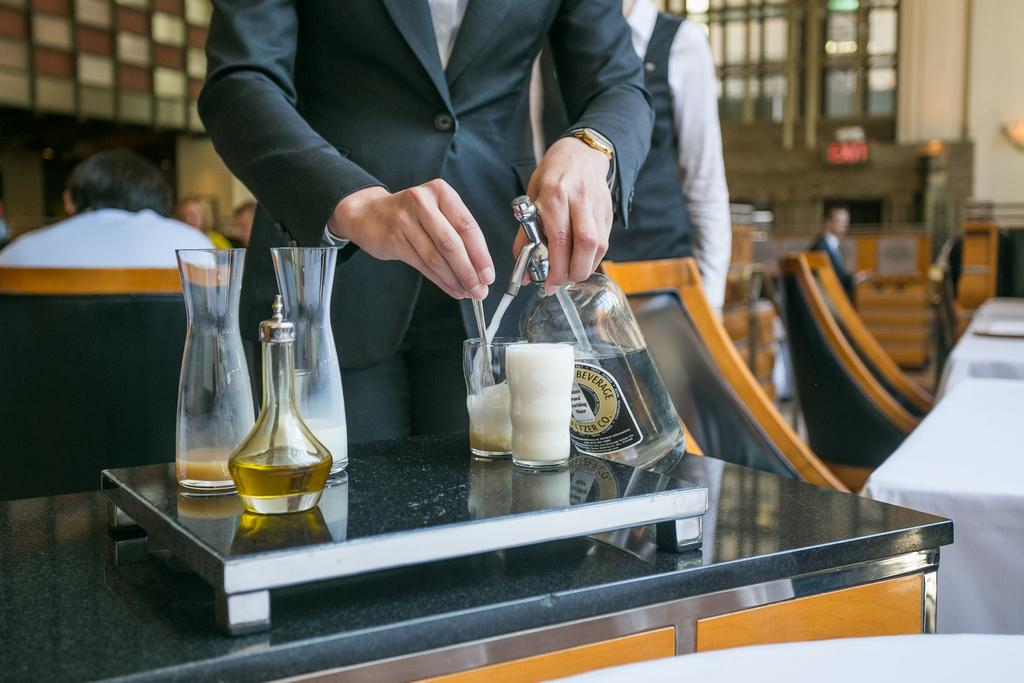What objects are on the table in the image? There are glasses and bottles on the table in the image. What is the person wearing in the image? The person is wearing a suit in the image. What is the person holding in the image? The person is holding a bottle in the image. What can be seen in the background of the image? There are chairs and tables in the background of the image. What are some people doing in the image? Some people are sitting on chairs in the image. What type of boundary is visible in the image? There is no boundary visible in the image. What station does the person in the suit work at? The image does not provide information about the person's occupation or workplace, so it cannot be determined from the image. 